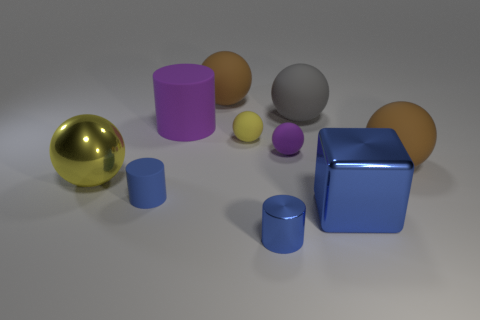The big purple rubber thing is what shape?
Offer a very short reply. Cylinder. There is a matte cylinder that is the same color as the shiny cube; what size is it?
Your answer should be very brief. Small. There is a shiny cylinder left of the gray sphere; how many big metal balls are on the right side of it?
Give a very brief answer. 0. What number of other objects are the same material as the large gray thing?
Offer a terse response. 6. Does the tiny blue cylinder left of the big purple object have the same material as the big yellow ball on the left side of the block?
Provide a short and direct response. No. Are there any other things that have the same shape as the big purple object?
Your answer should be compact. Yes. Does the large block have the same material as the brown object that is on the right side of the tiny blue shiny cylinder?
Your answer should be very brief. No. What is the color of the small object that is right of the small blue object on the right side of the blue thing to the left of the small metallic thing?
Keep it short and to the point. Purple. What is the shape of the metal object that is the same size as the blue rubber cylinder?
Provide a short and direct response. Cylinder. Is there any other thing that has the same size as the gray rubber sphere?
Give a very brief answer. Yes. 